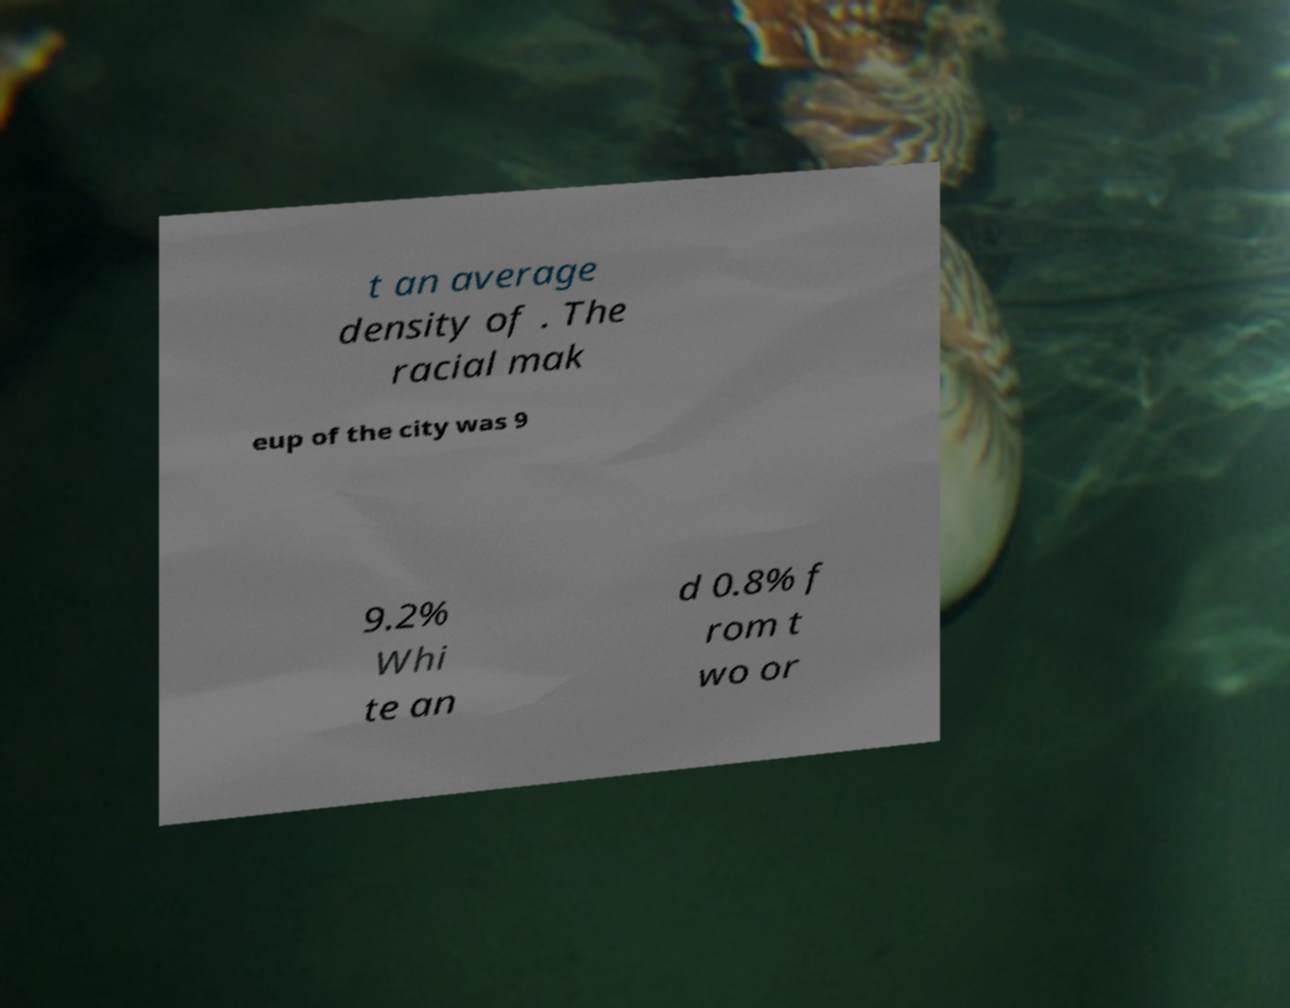There's text embedded in this image that I need extracted. Can you transcribe it verbatim? t an average density of . The racial mak eup of the city was 9 9.2% Whi te an d 0.8% f rom t wo or 